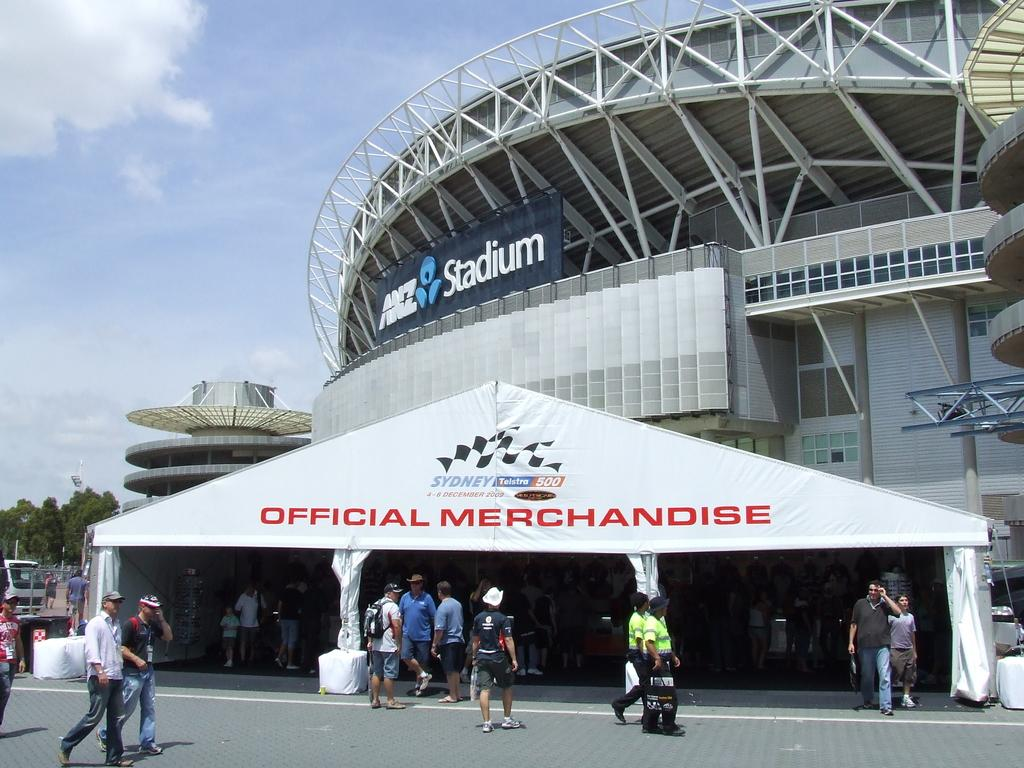How many people are in the image? There is a group of people in the image, but the exact number cannot be determined from the provided facts. What type of structure is visible in the image? There is a stadium in the image. What other objects can be seen in the image? There are trees, boards, and poles visible in the image. What is visible in the background of the image? The sky is visible in the background of the image, and there are clouds in the sky. What type of friction can be seen between the writer and the playground in the image? There is no writer or playground present in the image, so there is no friction to be observed between them. 